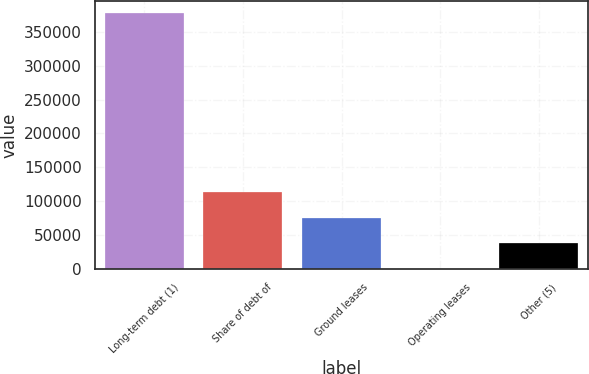Convert chart to OTSL. <chart><loc_0><loc_0><loc_500><loc_500><bar_chart><fcel>Long-term debt (1)<fcel>Share of debt of<fcel>Ground leases<fcel>Operating leases<fcel>Other (5)<nl><fcel>377120<fcel>113235<fcel>75537.6<fcel>142<fcel>37839.8<nl></chart> 